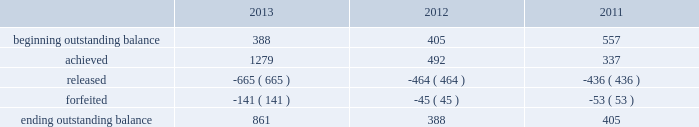Adobe systems incorporated notes to consolidated financial statements ( continued ) in the first quarter of fiscal 2013 , the executive compensation committee certified the actual performance achievement of participants in the 2012 performance share program ( the 201c2012 program 201d ) .
Based upon the achievement of specific and/or market- based performance goals outlined in the 2012 program , participants had the ability to receive up to 150% ( 150 % ) of the target number of shares originally granted .
Actual performance resulted in participants achieving 116% ( 116 % ) of target or approximately 1.3 million shares for the 2012 program .
One third of the shares under the 2012 program vested in the first quarter of fiscal 2013 and the remaining two thirds vest evenly on the following two anniversaries of the grant , contingent upon the recipient's continued service to adobe .
In the first quarter of fiscal 2012 , the executive compensation committee certified the actual performance achievement of participants in the 2011 performance share program ( the 201c2011 program 201d ) .
Based upon the achievement of goals outlined in the 2011 program , participants had the ability to receive up to 150% ( 150 % ) of the target number of shares originally granted .
Actual performance resulted in participants achieving 130% ( 130 % ) of target or approximately 0.5 million shares for the 2011 program .
One third of the shares under the 2011 program vested in the first quarter of fiscal 2012 and the remaining two thirds vest evenly on the following two annual anniversary dates of the grant , contingent upon the recipient's continued service to adobe .
In the first quarter of fiscal 2011 , the executive compensation committee certified the actual performance achievement of participants in the 2010 performance share program ( the 201c2010 program 201d ) .
Based upon the achievement of goals outlined in the 2010 program , participants had the ability to receive up to 150% ( 150 % ) of the target number of shares originally granted .
Actual performance resulted in participants achieving 135% ( 135 % ) of target or approximately 0.3 million shares for the 2010 program .
One third of the shares under the 2011 program vested in the first quarter of fiscal 2012 and the remaining two thirds vest evenly on the following two annual anniversary dates of the grant , contingent upon the recipient's continued service to adobe .
The table sets forth the summary of performance share activity under our 2010 , 2011 and 2012 programs , based upon share awards actually achieved , for the fiscal years ended november 29 , 2013 , november 30 , 2012 and december 2 , 2011 ( in thousands ) : .
The total fair value of performance awards vested during fiscal 2013 , 2012 and 2011 was $ 25.4 million , $ 14.4 million and $ 14.8 million , respectively. .
What is the net increase in the balance of outstanding shares during 2013? 
Computations: (861 - 388)
Answer: 473.0. Adobe systems incorporated notes to consolidated financial statements ( continued ) in the first quarter of fiscal 2013 , the executive compensation committee certified the actual performance achievement of participants in the 2012 performance share program ( the 201c2012 program 201d ) .
Based upon the achievement of specific and/or market- based performance goals outlined in the 2012 program , participants had the ability to receive up to 150% ( 150 % ) of the target number of shares originally granted .
Actual performance resulted in participants achieving 116% ( 116 % ) of target or approximately 1.3 million shares for the 2012 program .
One third of the shares under the 2012 program vested in the first quarter of fiscal 2013 and the remaining two thirds vest evenly on the following two anniversaries of the grant , contingent upon the recipient's continued service to adobe .
In the first quarter of fiscal 2012 , the executive compensation committee certified the actual performance achievement of participants in the 2011 performance share program ( the 201c2011 program 201d ) .
Based upon the achievement of goals outlined in the 2011 program , participants had the ability to receive up to 150% ( 150 % ) of the target number of shares originally granted .
Actual performance resulted in participants achieving 130% ( 130 % ) of target or approximately 0.5 million shares for the 2011 program .
One third of the shares under the 2011 program vested in the first quarter of fiscal 2012 and the remaining two thirds vest evenly on the following two annual anniversary dates of the grant , contingent upon the recipient's continued service to adobe .
In the first quarter of fiscal 2011 , the executive compensation committee certified the actual performance achievement of participants in the 2010 performance share program ( the 201c2010 program 201d ) .
Based upon the achievement of goals outlined in the 2010 program , participants had the ability to receive up to 150% ( 150 % ) of the target number of shares originally granted .
Actual performance resulted in participants achieving 135% ( 135 % ) of target or approximately 0.3 million shares for the 2010 program .
One third of the shares under the 2011 program vested in the first quarter of fiscal 2012 and the remaining two thirds vest evenly on the following two annual anniversary dates of the grant , contingent upon the recipient's continued service to adobe .
The table sets forth the summary of performance share activity under our 2010 , 2011 and 2012 programs , based upon share awards actually achieved , for the fiscal years ended november 29 , 2013 , november 30 , 2012 and december 2 , 2011 ( in thousands ) : .
The total fair value of performance awards vested during fiscal 2013 , 2012 and 2011 was $ 25.4 million , $ 14.4 million and $ 14.8 million , respectively. .
What is the net increase in the balance of outstanding shares during 2012? 
Computations: (388 - 405)
Answer: -17.0. 